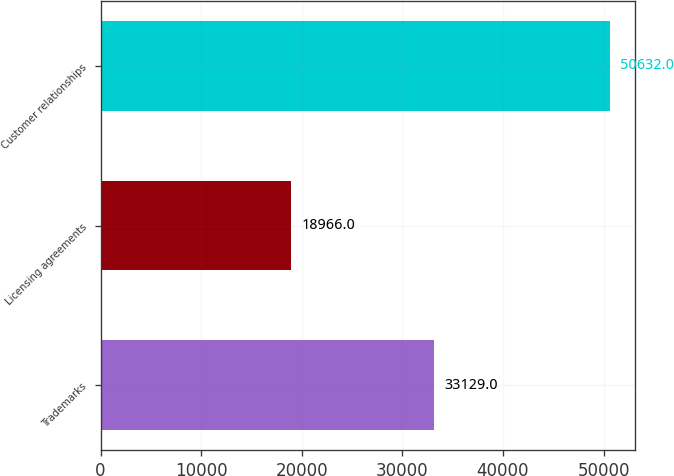<chart> <loc_0><loc_0><loc_500><loc_500><bar_chart><fcel>Trademarks<fcel>Licensing agreements<fcel>Customer relationships<nl><fcel>33129<fcel>18966<fcel>50632<nl></chart> 